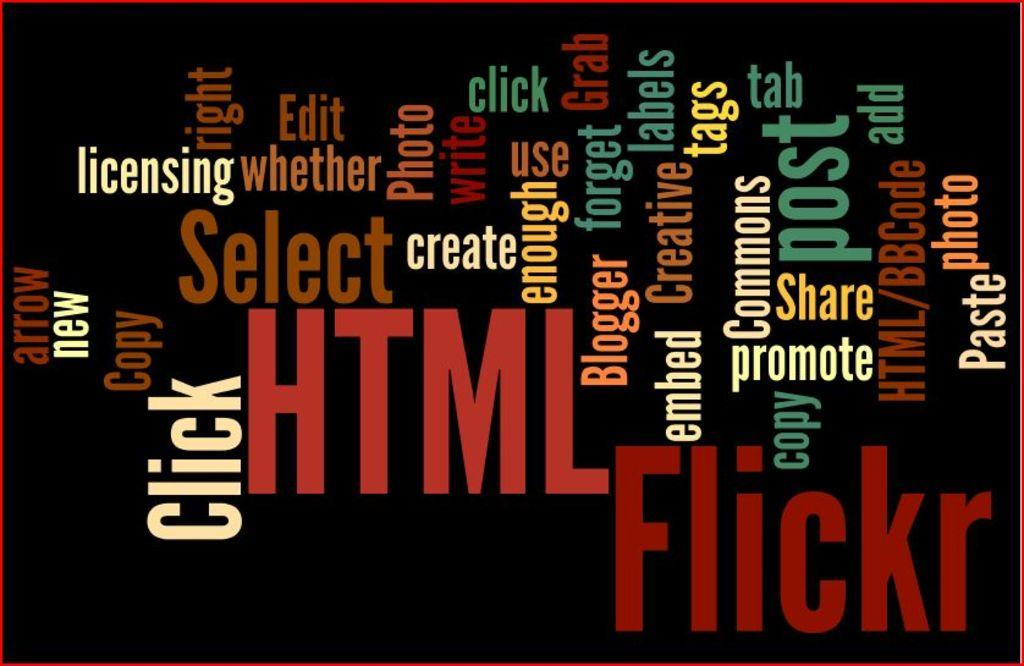Provide a one-sentence caption for the provided image. Numerous, various words, which includes "edit", "post", and "share", on a black background. 